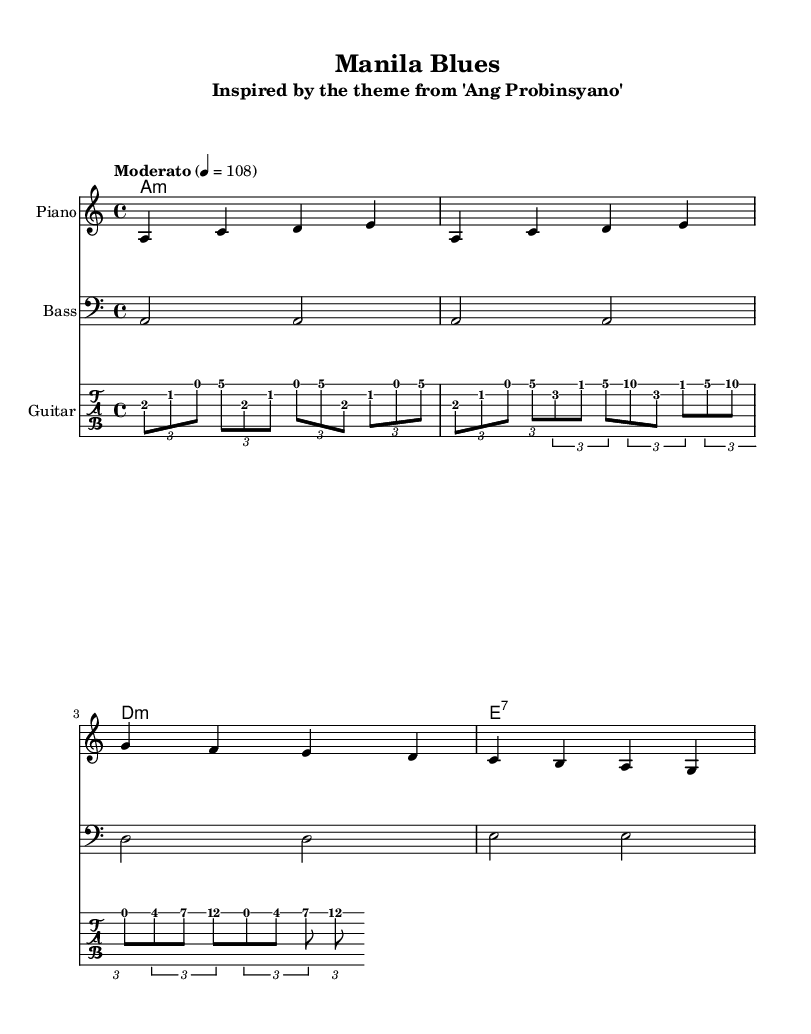What is the key signature of this music? The key signature is A minor, which has no sharps or flats, indicated by the absence of any sharps or flats in the key signature section of the sheet music.
Answer: A minor What is the time signature of this music? The time signature is 4/4, meaning there are four beats in each measure, and the quarter note gets one beat, as shown at the beginning of the score.
Answer: 4/4 What is the tempo marking for this music? The tempo marking is "Moderato," which indicates a moderate speed, indicated at the beginning of the score alongside the note value of 108 beats per minute.
Answer: Moderato How many measures are in the melody? There are four measures in the melody, as shown by the grouping of notes and bar lines that separate them in the score.
Answer: Four What is the chord progression shown in the harmonies? The chord progression is A minor, A minor, D minor, E7, as indicated in the chord names written above the staff, and the specific chords provided in the chord mode notation.
Answer: A minor, A minor, D minor, E7 What is the instrument labeled for the bass staff? The instrument labeled for the bass staff is "Bass," indicated at the beginning of that staff to specify the playing range and clef used.
Answer: Bass What type of musical genre is this piece classified as? This piece is classified as Blues, as inferred from the title "Manila Blues" and the structure and style of the music, which follows typical blues patterns.
Answer: Blues 